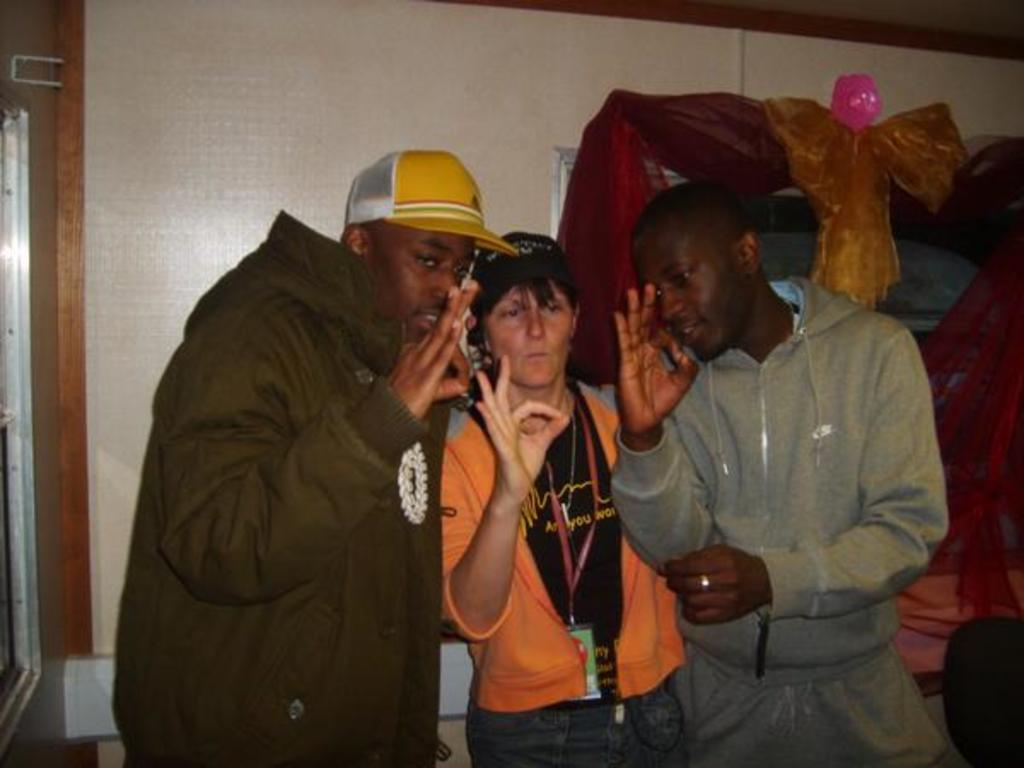How many people are in the image? There are three persons in the image. What are the persons doing in the image? The persons are standing and showing a super sign. What can be seen in the right corner of the image? There are clothes and other objects in the right corner of the image. What type of doll is sitting on the rock in the image? There is no doll or rock present in the image. 